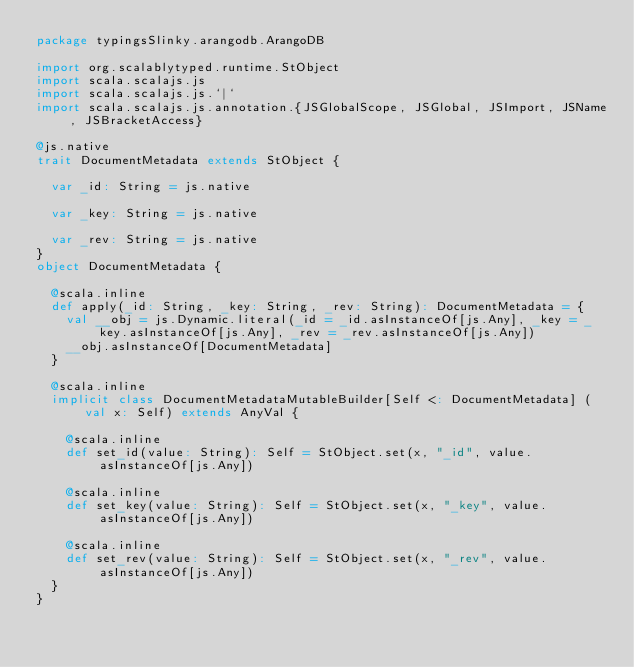Convert code to text. <code><loc_0><loc_0><loc_500><loc_500><_Scala_>package typingsSlinky.arangodb.ArangoDB

import org.scalablytyped.runtime.StObject
import scala.scalajs.js
import scala.scalajs.js.`|`
import scala.scalajs.js.annotation.{JSGlobalScope, JSGlobal, JSImport, JSName, JSBracketAccess}

@js.native
trait DocumentMetadata extends StObject {
  
  var _id: String = js.native
  
  var _key: String = js.native
  
  var _rev: String = js.native
}
object DocumentMetadata {
  
  @scala.inline
  def apply(_id: String, _key: String, _rev: String): DocumentMetadata = {
    val __obj = js.Dynamic.literal(_id = _id.asInstanceOf[js.Any], _key = _key.asInstanceOf[js.Any], _rev = _rev.asInstanceOf[js.Any])
    __obj.asInstanceOf[DocumentMetadata]
  }
  
  @scala.inline
  implicit class DocumentMetadataMutableBuilder[Self <: DocumentMetadata] (val x: Self) extends AnyVal {
    
    @scala.inline
    def set_id(value: String): Self = StObject.set(x, "_id", value.asInstanceOf[js.Any])
    
    @scala.inline
    def set_key(value: String): Self = StObject.set(x, "_key", value.asInstanceOf[js.Any])
    
    @scala.inline
    def set_rev(value: String): Self = StObject.set(x, "_rev", value.asInstanceOf[js.Any])
  }
}
</code> 